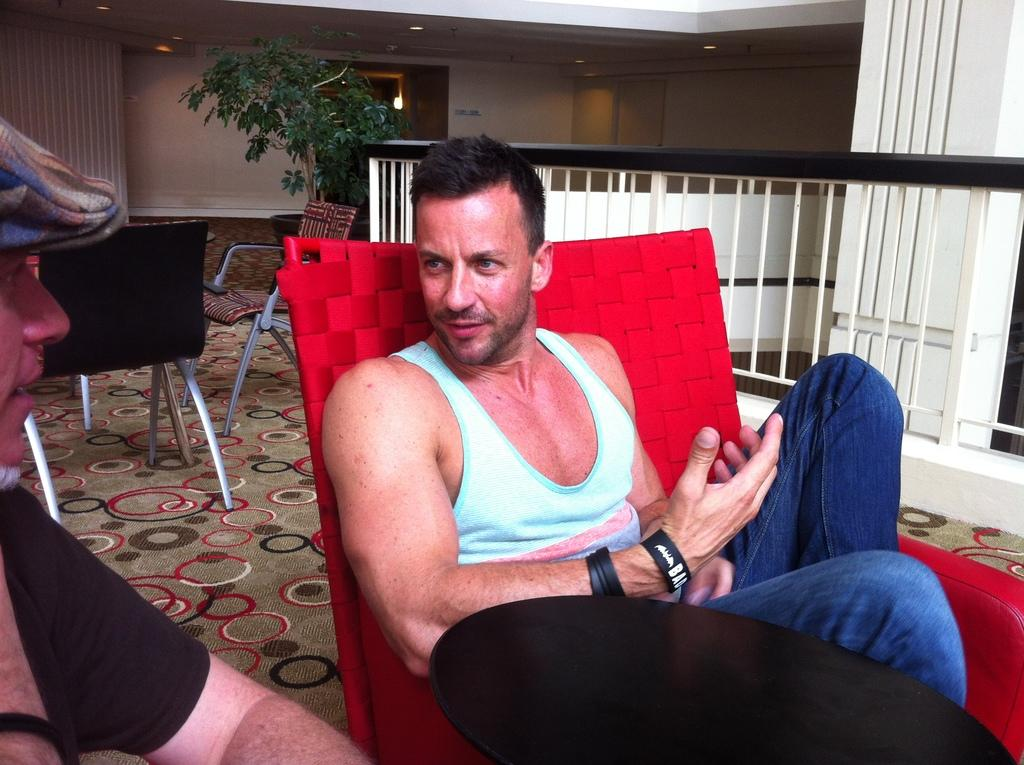What is the man in the image doing? The man is sitting in a chair in the image. Can you describe the other person in the image? There is another person in the image, but their actions or position are not specified. How many chairs are visible in the image? There is at least one chair in the image, as the man is sitting in it. What type of vegetation is present in the image? There is a plant in the image. What architectural feature can be seen in the image? There is a door in the image. What type of flooring is visible in the image? There is a carpet in the image. What type of sheet is draped over the rose in the image? There is no rose or sheet present in the image. 